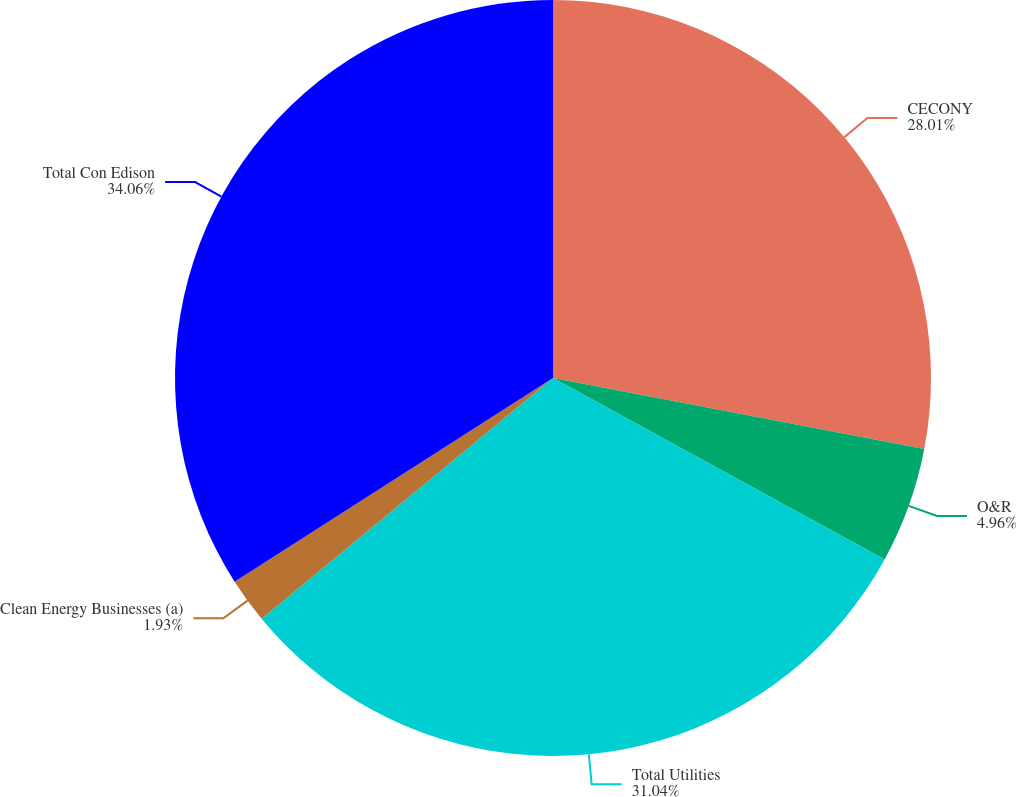Convert chart. <chart><loc_0><loc_0><loc_500><loc_500><pie_chart><fcel>CECONY<fcel>O&R<fcel>Total Utilities<fcel>Clean Energy Businesses (a)<fcel>Total Con Edison<nl><fcel>28.01%<fcel>4.96%<fcel>31.04%<fcel>1.93%<fcel>34.06%<nl></chart> 